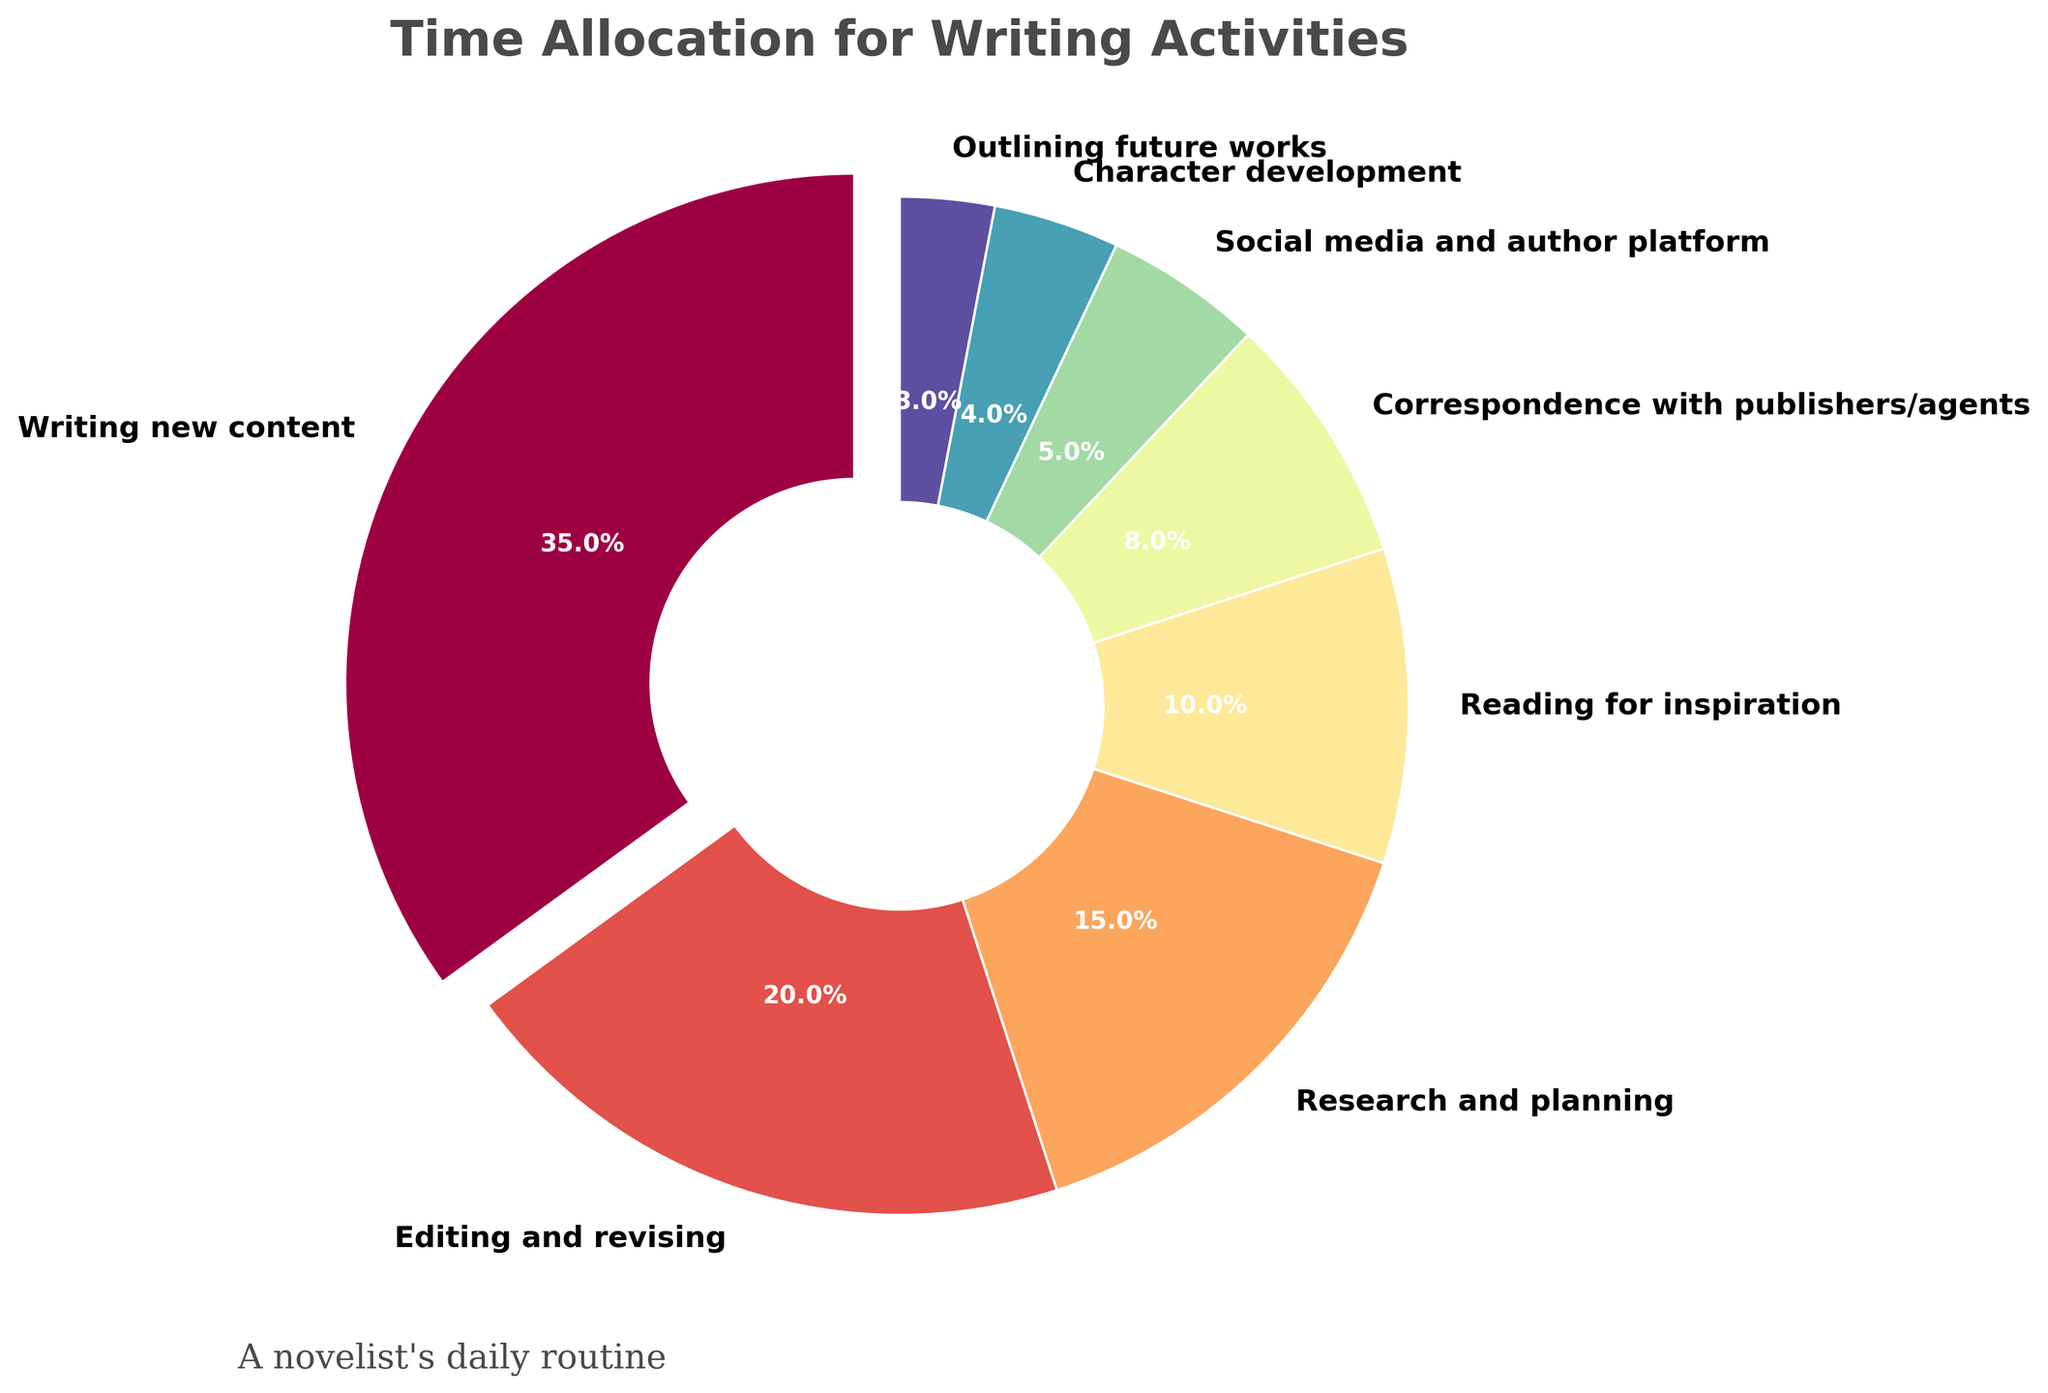What is the percentage of time allocated to Writing new content? Look at the largest wedge of the pie chart, which corresponds to Writing new content. The pie chart annotation shows it as 35%.
Answer: 35% Which activity takes up more time: Social media and author platform or Editing and revising? Compare the pie segments labeled Social media and author platform (5%) and Editing and revising (20%). Editing and revising has a higher percentage than Social media and author platform.
Answer: Editing and revising What is the combined percentage of time spent on Research and planning, and Character development? Locate the segments for Research and planning (15%) and Character development (4%), then add these percentages together. 15% + 4% = 19%.
Answer: 19% Which activity has the smallest allocation of time? Identify the smallest wedge in the pie chart, which is labeled Outlining future works with a percentage of 3%.
Answer: Outlining future works How much more percentage of time is spent Writing new content compared to Reading for inspiration? Compare the percentages of Writing new content (35%) and Reading for inspiration (10%). Subtract the latter from the former. 35% - 10% = 25%.
Answer: 25% Is more time allocated to Correspondence with publishers/agents or Research and planning? Compare the percentages of Correspondence with publishers/agents (8%) and Research and planning (15%). Research and planning has a higher percentage.
Answer: Research and planning What is the total percentage of time spent on activities related to direct content creation (Writing new content, Editing and revising, and Character development)? Sum the percentages of Writing new content (35%), Editing and revising (20%) and Character development (4%). 35% + 20% + 4% = 59%.
Answer: 59% What is the color of the segment representing Reading for inspiration? Identify the color of the segment that has a 10% allocation labeled Reading for inspiration, which is visually observed in the pie chart.
Answer: Light blue (or the specific color observed in the chart) What two activities combined equal the percentage allocated to Writing new content? Look for the pair of activities whose combined percentages equal Writing new content (35%). Research and planning (15%) plus Editing and revising (20%) equals 35%.
Answer: Research and planning and Editing and revising Compare the wedge color of Correspondence with publishers/agents to Reading for inspiration. Are they distinct? Check the visual color representation of both Correspondence with publishers/agents (8%) and Reading for inspiration (10%). Visually confirm that these two segments have distinct colors.
Answer: Yes 